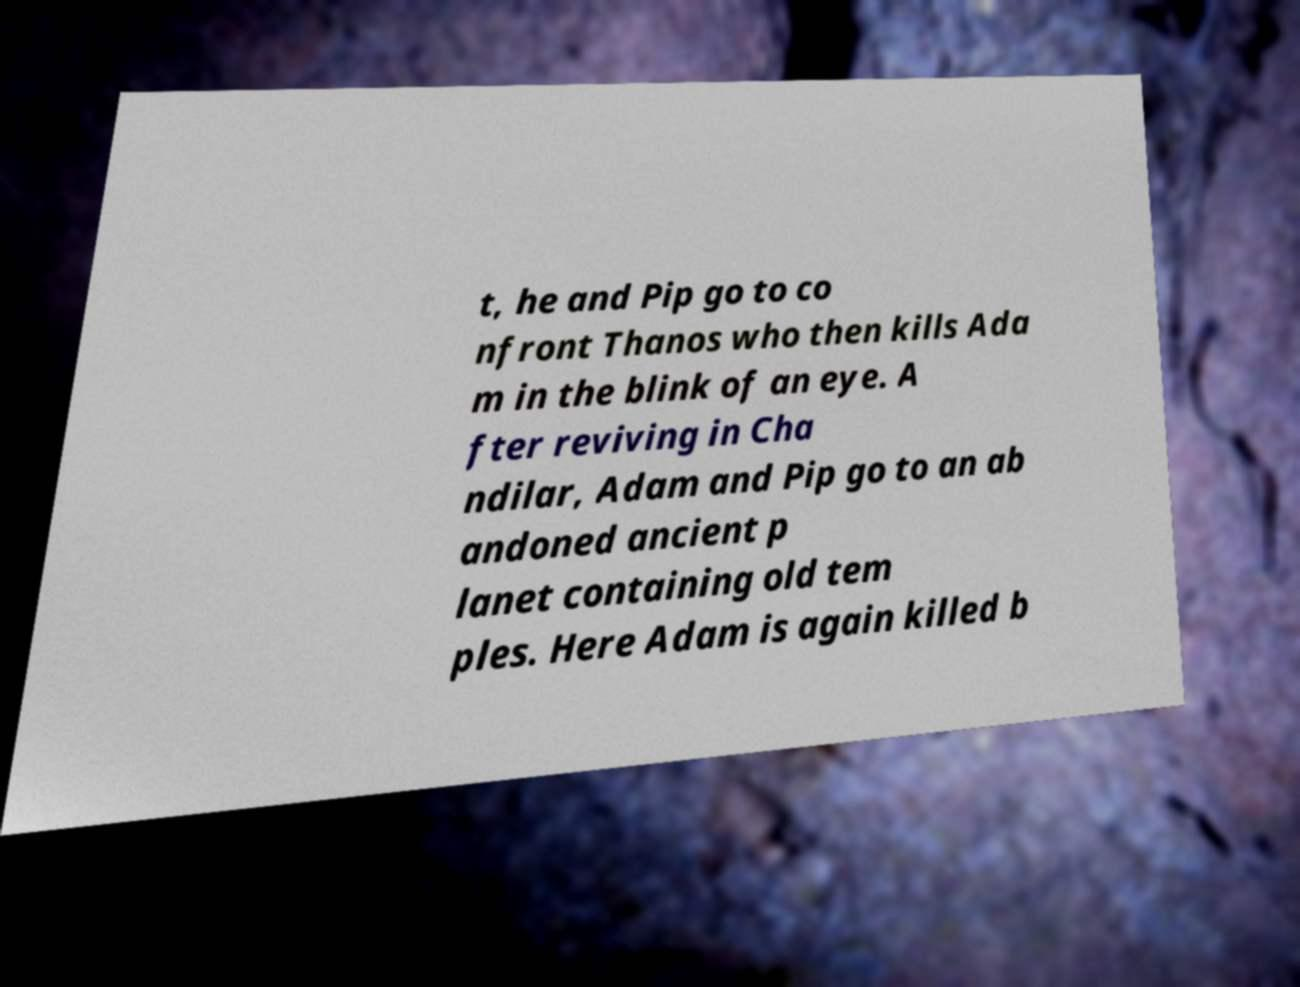Please identify and transcribe the text found in this image. t, he and Pip go to co nfront Thanos who then kills Ada m in the blink of an eye. A fter reviving in Cha ndilar, Adam and Pip go to an ab andoned ancient p lanet containing old tem ples. Here Adam is again killed b 